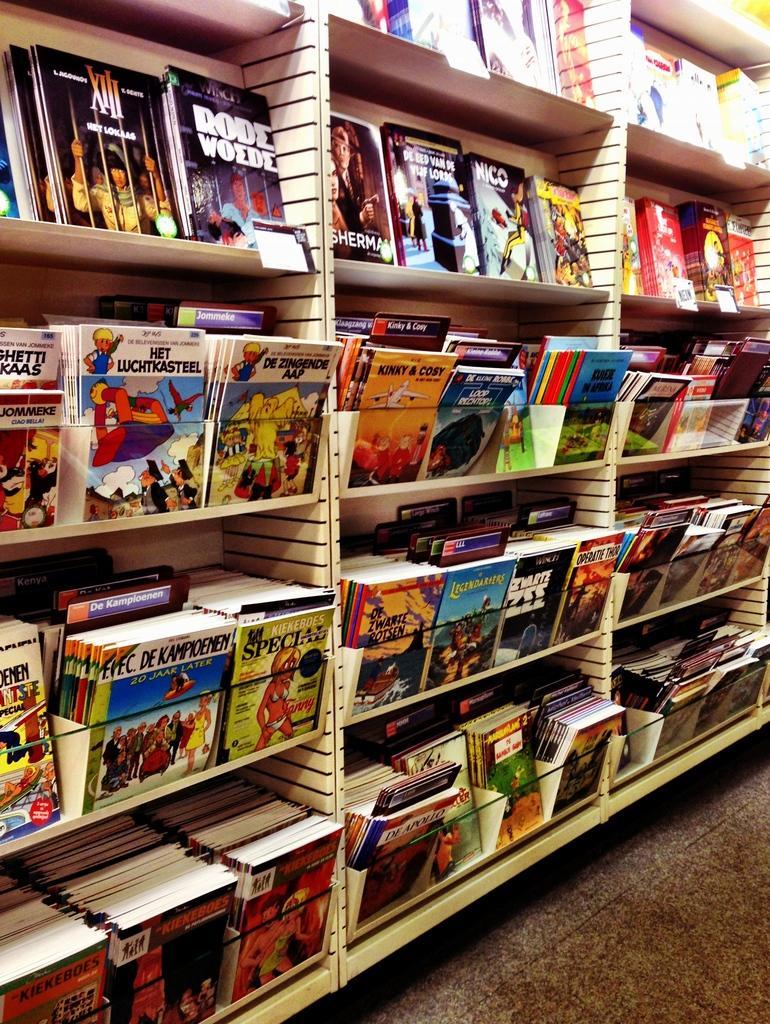Could you give a brief overview of what you see in this image? In the image there are cabinets and there are plenty of books kept in the each self of those cabinets. 